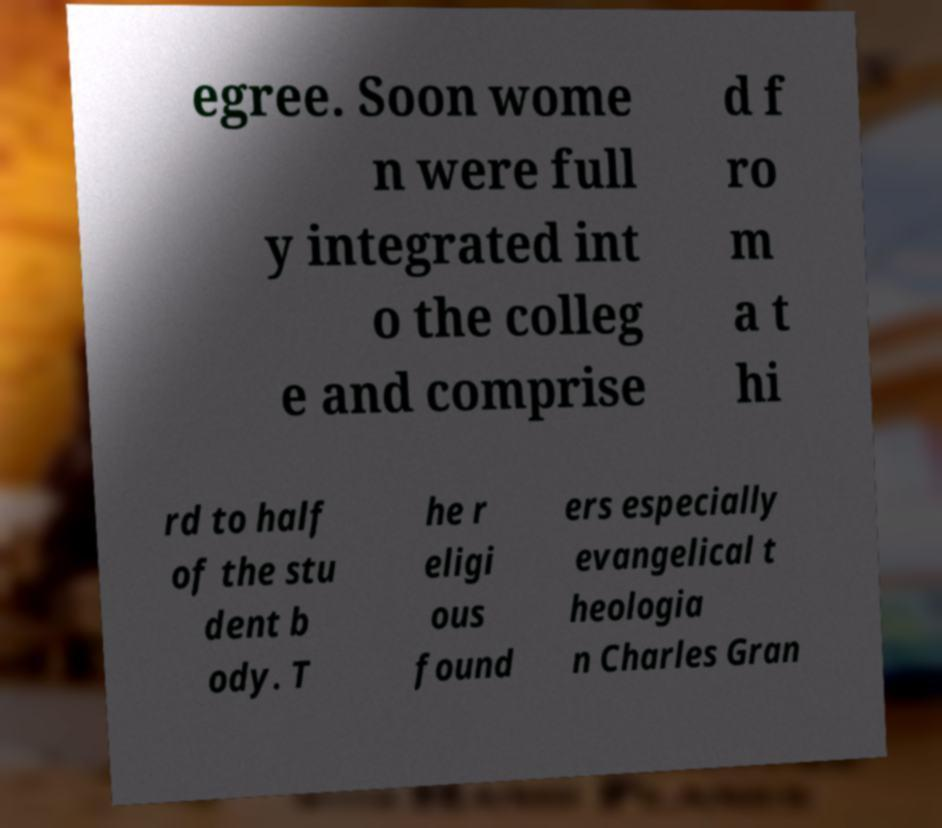What messages or text are displayed in this image? I need them in a readable, typed format. egree. Soon wome n were full y integrated int o the colleg e and comprise d f ro m a t hi rd to half of the stu dent b ody. T he r eligi ous found ers especially evangelical t heologia n Charles Gran 